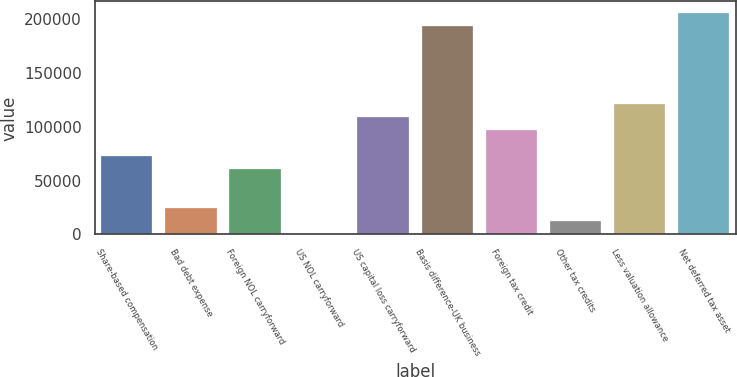Convert chart to OTSL. <chart><loc_0><loc_0><loc_500><loc_500><bar_chart><fcel>Share-based compensation<fcel>Bad debt expense<fcel>Foreign NOL carryforward<fcel>US NOL carryforward<fcel>US capital loss carryforward<fcel>Basis difference-UK business<fcel>Foreign tax credit<fcel>Other tax credits<fcel>Less valuation allowance<fcel>Net deferred tax asset<nl><fcel>73032<fcel>24506<fcel>60900.5<fcel>243<fcel>109426<fcel>194347<fcel>97295<fcel>12374.5<fcel>121558<fcel>206478<nl></chart> 